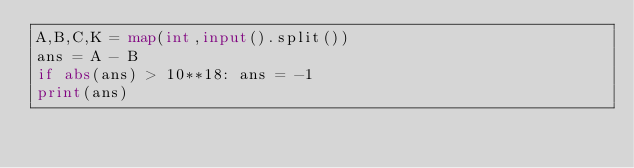Convert code to text. <code><loc_0><loc_0><loc_500><loc_500><_Python_>A,B,C,K = map(int,input().split())
ans = A - B
if abs(ans) > 10**18: ans = -1
print(ans)</code> 